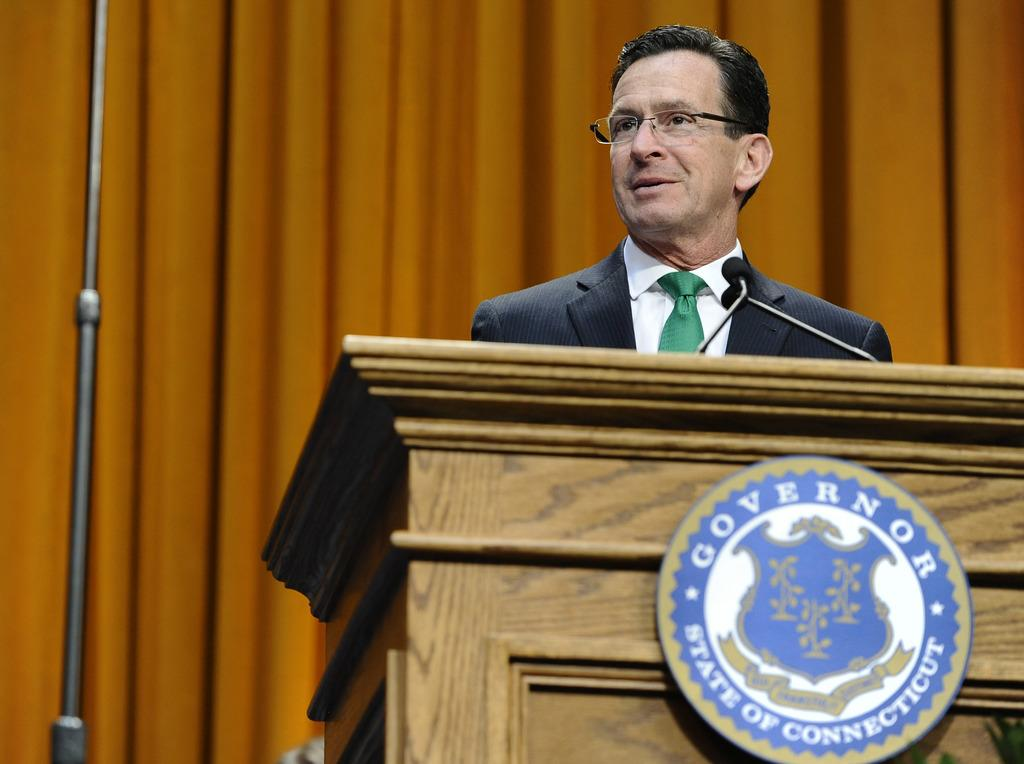What is the person in the image doing? The person is standing behind a podium. What is on the podium? The podium has a logo on it and a microphone with stands. What can be seen behind the person? There is an iron rod and a wall behind the person. What type of patch is sewn onto the person's wrist in the image? There is no patch visible on the person's wrist in the image. 